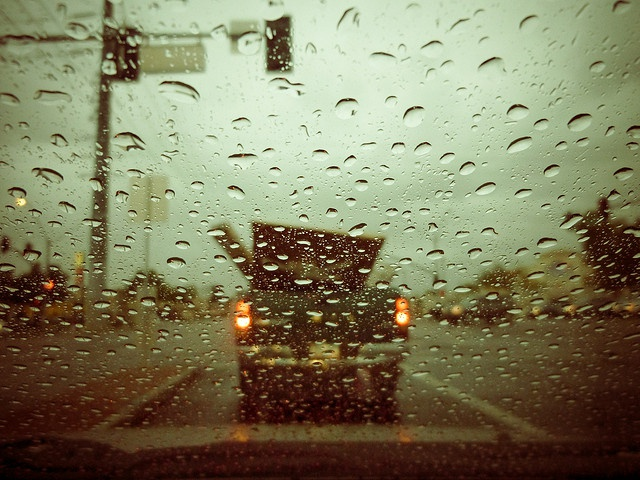Describe the objects in this image and their specific colors. I can see truck in olive, black, and maroon tones, car in olive, black, and maroon tones, car in olive, maroon, and black tones, traffic light in olive, maroon, black, and darkgreen tones, and traffic light in olive, black, and maroon tones in this image. 